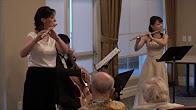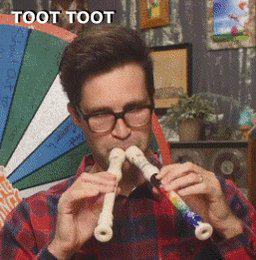The first image is the image on the left, the second image is the image on the right. For the images shown, is this caption "In the right image, a male is holding two flute-like instruments to his mouth so they form a V-shape." true? Answer yes or no. Yes. The first image is the image on the left, the second image is the image on the right. Considering the images on both sides, is "Each musician is holding two instruments." valid? Answer yes or no. No. 